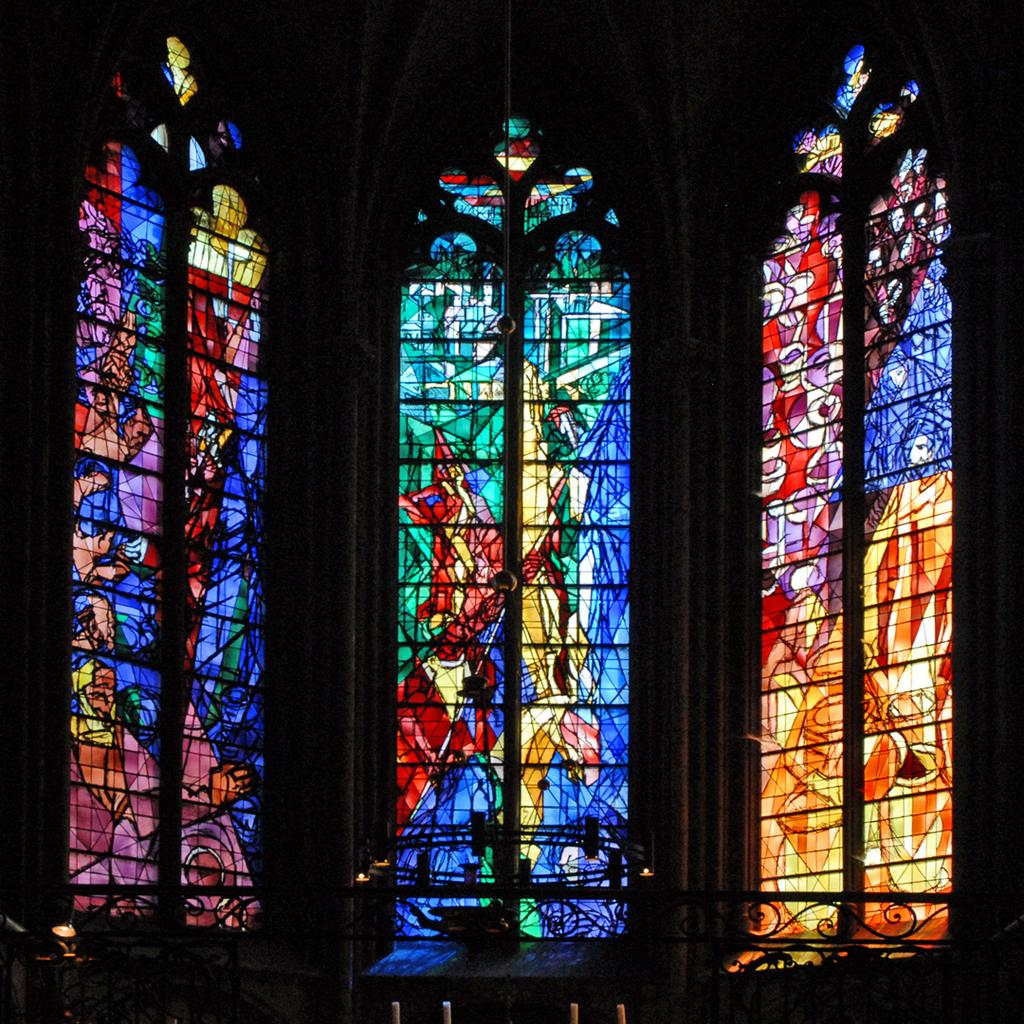How many windows are visible in the image? There are three windows in the image. What is unique about the windows in the image? The windows have stained glass. What type of plate is being used to wage war in the image? There is no plate or war depicted in the image; it only features three windows with stained glass. 